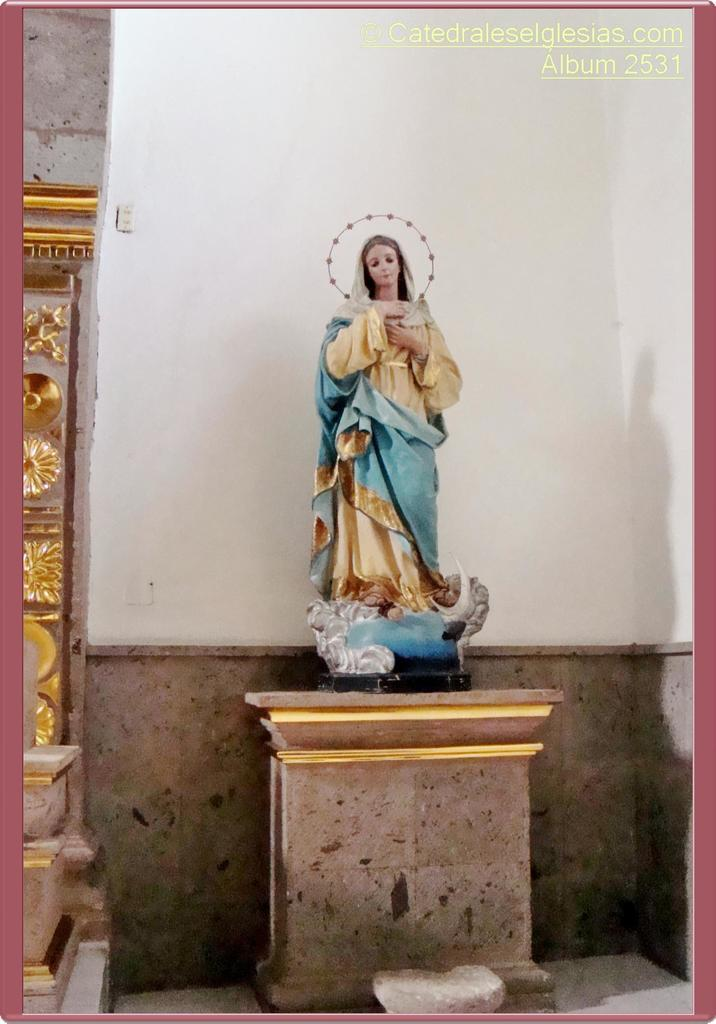What is the main subject of the image? There is a statue of a woman in the image. How is the statue positioned in the image? The statue is on a stand. What can be seen in the background of the image? There is a wall visible in the background of the image. What type of appliance is being used by the woman in the image? There is no appliance being used by the woman in the image, as the subject is a statue and not a living person. 